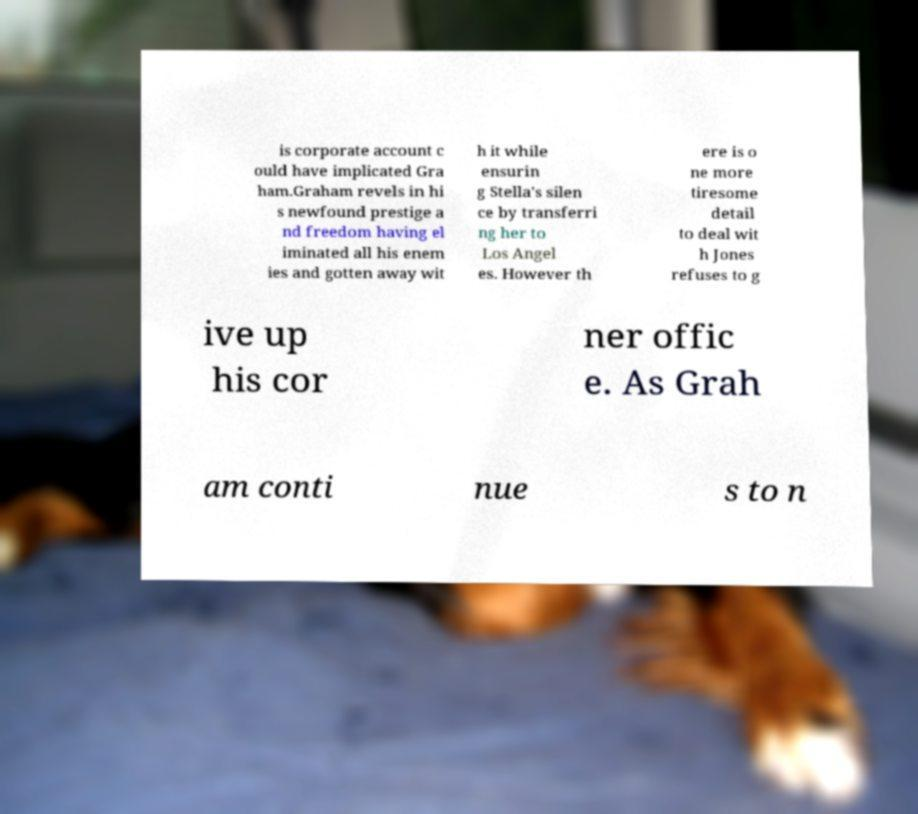Can you read and provide the text displayed in the image?This photo seems to have some interesting text. Can you extract and type it out for me? is corporate account c ould have implicated Gra ham.Graham revels in hi s newfound prestige a nd freedom having el iminated all his enem ies and gotten away wit h it while ensurin g Stella's silen ce by transferri ng her to Los Angel es. However th ere is o ne more tiresome detail to deal wit h Jones refuses to g ive up his cor ner offic e. As Grah am conti nue s to n 